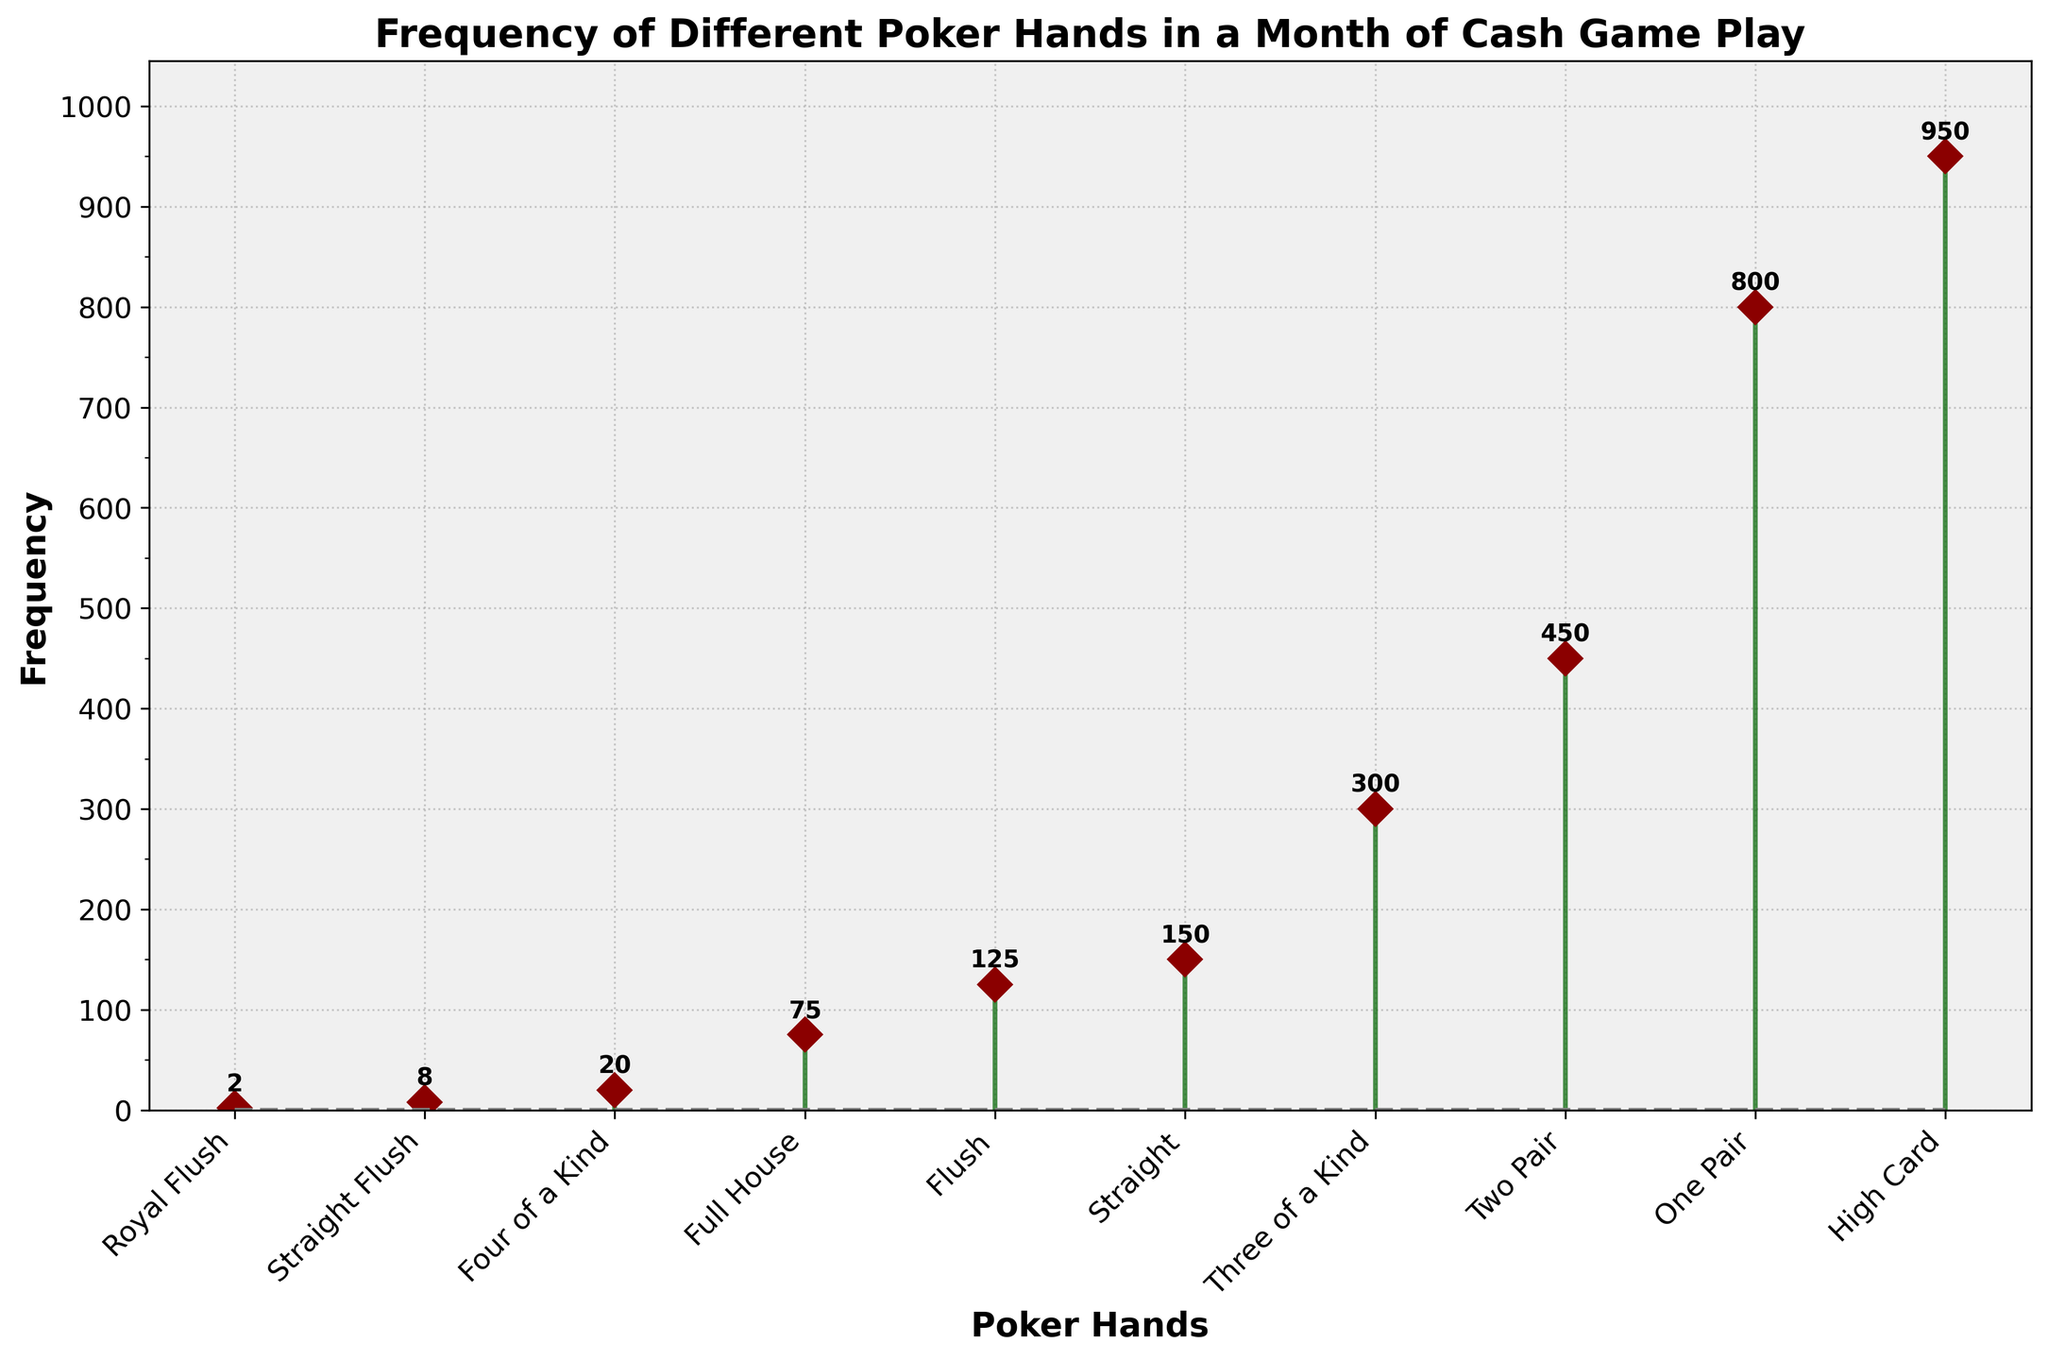What is the title of the plot? The title is usually placed at the top center of the plot. In this figure, we can see bold, large text that gives information about the main purpose of the plot.
Answer: Frequency of Different Poker Hands in a Month of Cash Game Play How many different poker hands are represented in the plot? To determine this, we count the number of unique labels on the x-axis, which represent poker hands.
Answer: 10 Which poker hand appears most frequently? By looking at the stem plot, identify the hand with the highest frequency value. From the markers and annotations, see which poker hand has the largest value.
Answer: High Card What's the second least frequent poker hand? First, identify the least frequent hand, Royal Flush. Then, find the next lowest frequency value among the remaining hands.
Answer: Straight Flush (8) Which poker hand has a frequency closest to 500? Scan the frequency values and identify which poker hand's frequency is nearest to 500.
Answer: One Pair (800) 